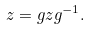<formula> <loc_0><loc_0><loc_500><loc_500>z = g z g ^ { - 1 } .</formula> 